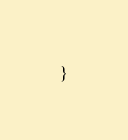Convert code to text. <code><loc_0><loc_0><loc_500><loc_500><_Scala_>
}
</code> 